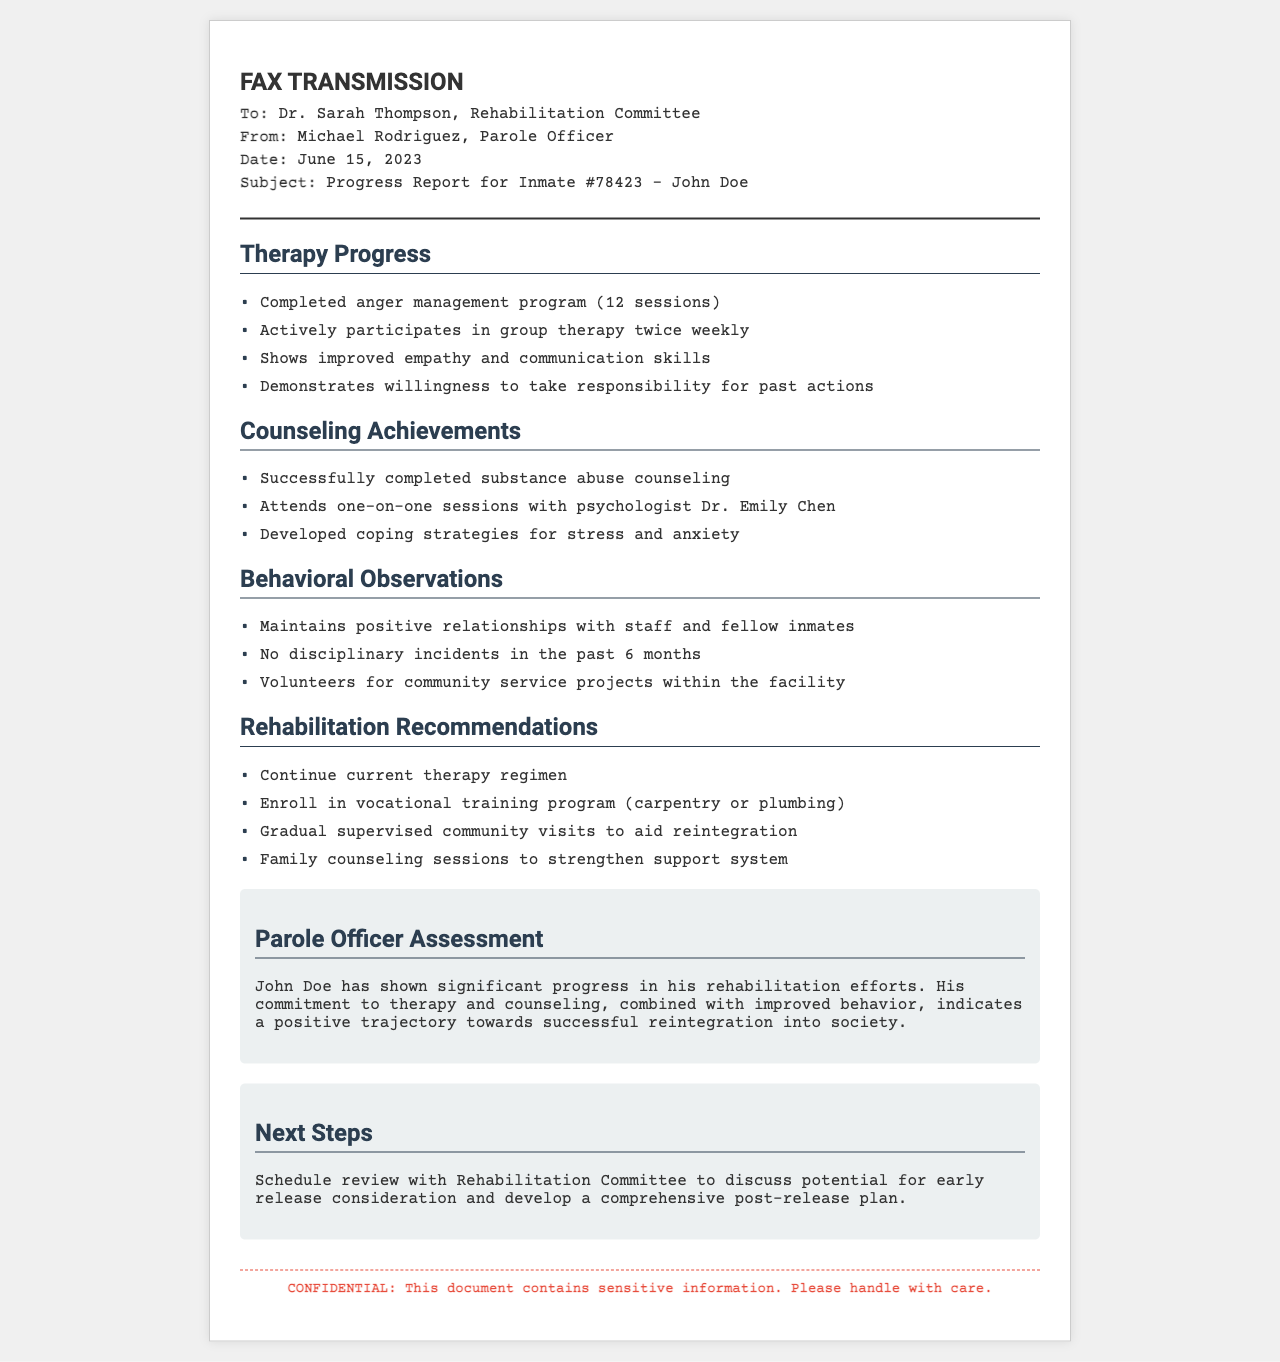What is the date of the fax? The date of the fax is clearly stated in the document header.
Answer: June 15, 2023 Who is the parole officer? The name of the parole officer is identified in the 'From' section of the document.
Answer: Michael Rodriguez How many sessions did John Doe complete in the anger management program? The document specifies the number of sessions completed in the therapy section.
Answer: 12 sessions What is one of the recommendations for rehabilitation? Recommendations for rehabilitation are listed under a specific section in the document.
Answer: Enroll in vocational training program How many disciplinary incidents occurred in the past 6 months? This information is provided in the behavioral observations section of the document.
Answer: No What is the main focus of the 'Next Steps' section? The 'Next Steps' section outlines future actions detailed in the document.
Answer: Schedule review with Rehabilitation Committee What is the name of the psychologist John Doe is attending sessions with? The psychologist's name is mentioned in the counseling achievements section.
Answer: Dr. Emily Chen What type of community projects has John Doe volunteered for? The document mentions the type of service done by John Doe.
Answer: Community service projects What is the significance of the document's confidentiality note? The confidentiality note informs the reader about the sensitivity of the information.
Answer: Sensitive information 